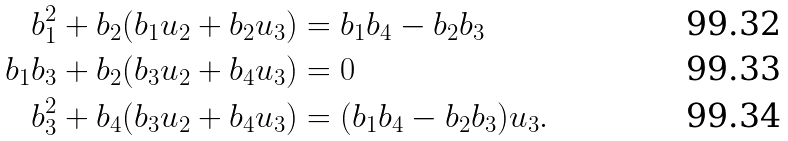Convert formula to latex. <formula><loc_0><loc_0><loc_500><loc_500>b _ { 1 } ^ { 2 } + b _ { 2 } ( b _ { 1 } u _ { 2 } + b _ { 2 } u _ { 3 } ) & = b _ { 1 } b _ { 4 } - b _ { 2 } b _ { 3 } \\ b _ { 1 } b _ { 3 } + b _ { 2 } ( b _ { 3 } u _ { 2 } + b _ { 4 } u _ { 3 } ) & = 0 \\ b _ { 3 } ^ { 2 } + b _ { 4 } ( b _ { 3 } u _ { 2 } + b _ { 4 } u _ { 3 } ) & = ( b _ { 1 } b _ { 4 } - b _ { 2 } b _ { 3 } ) u _ { 3 } .</formula> 